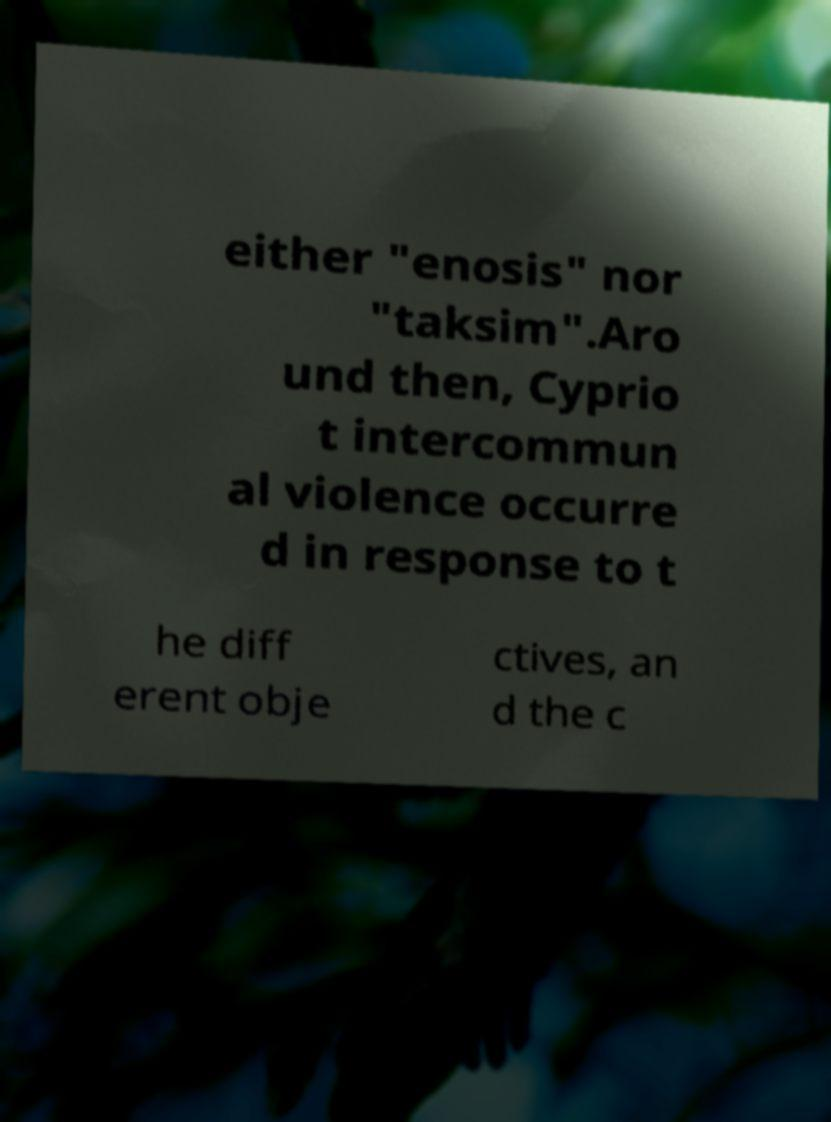For documentation purposes, I need the text within this image transcribed. Could you provide that? either "enosis" nor "taksim".Aro und then, Cyprio t intercommun al violence occurre d in response to t he diff erent obje ctives, an d the c 